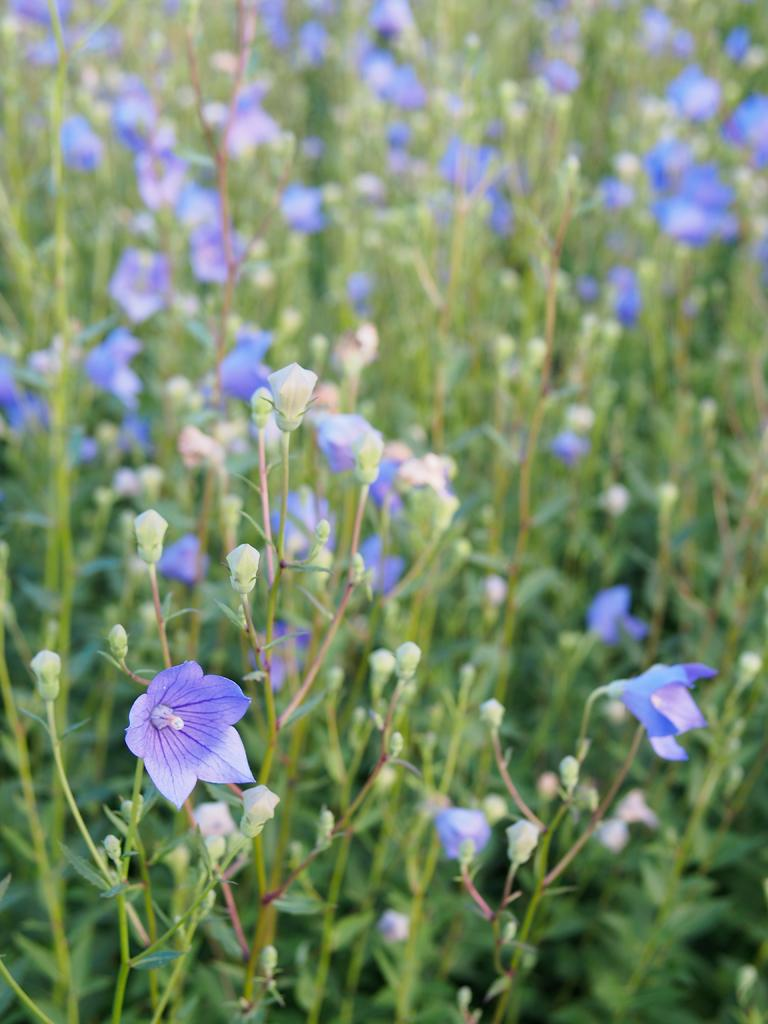What types of living organisms are present in the image? There are many plants in the image. What specific features can be observed on the plants? The plants have flowers. How many sticks are used to support the plants in the image? There is no mention of sticks being used to support the plants in the image. 